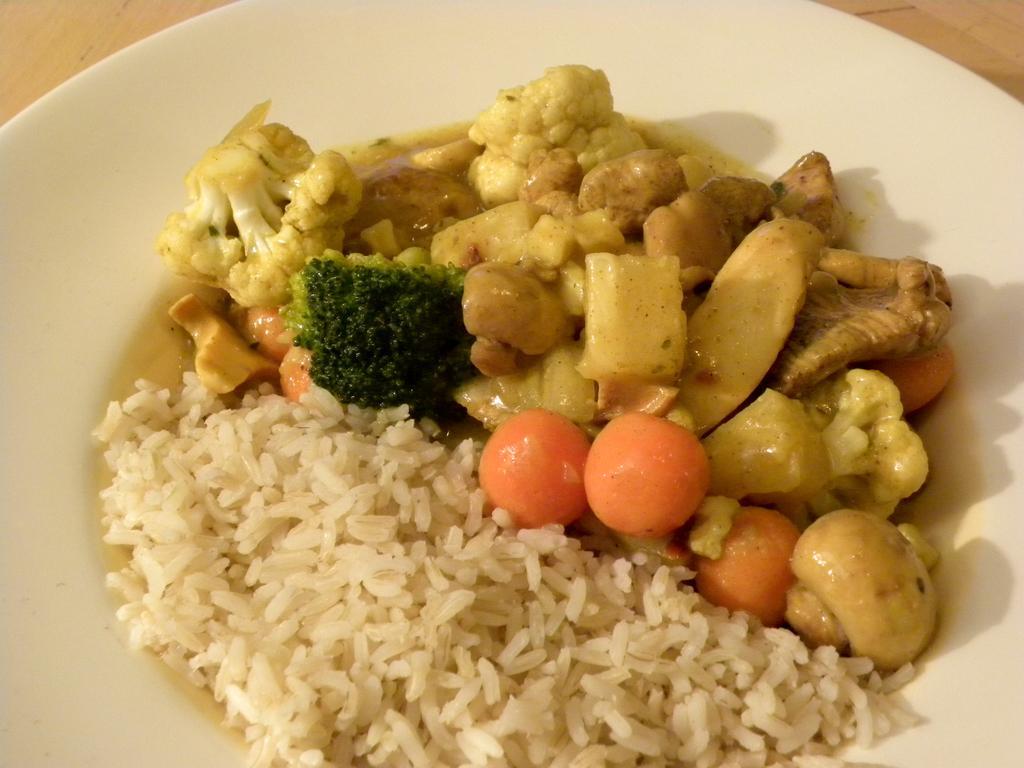Can you describe this image briefly? In this image I can see food, and the food is in white, orange, green and brown color in the pale, and the plate is in white color. 